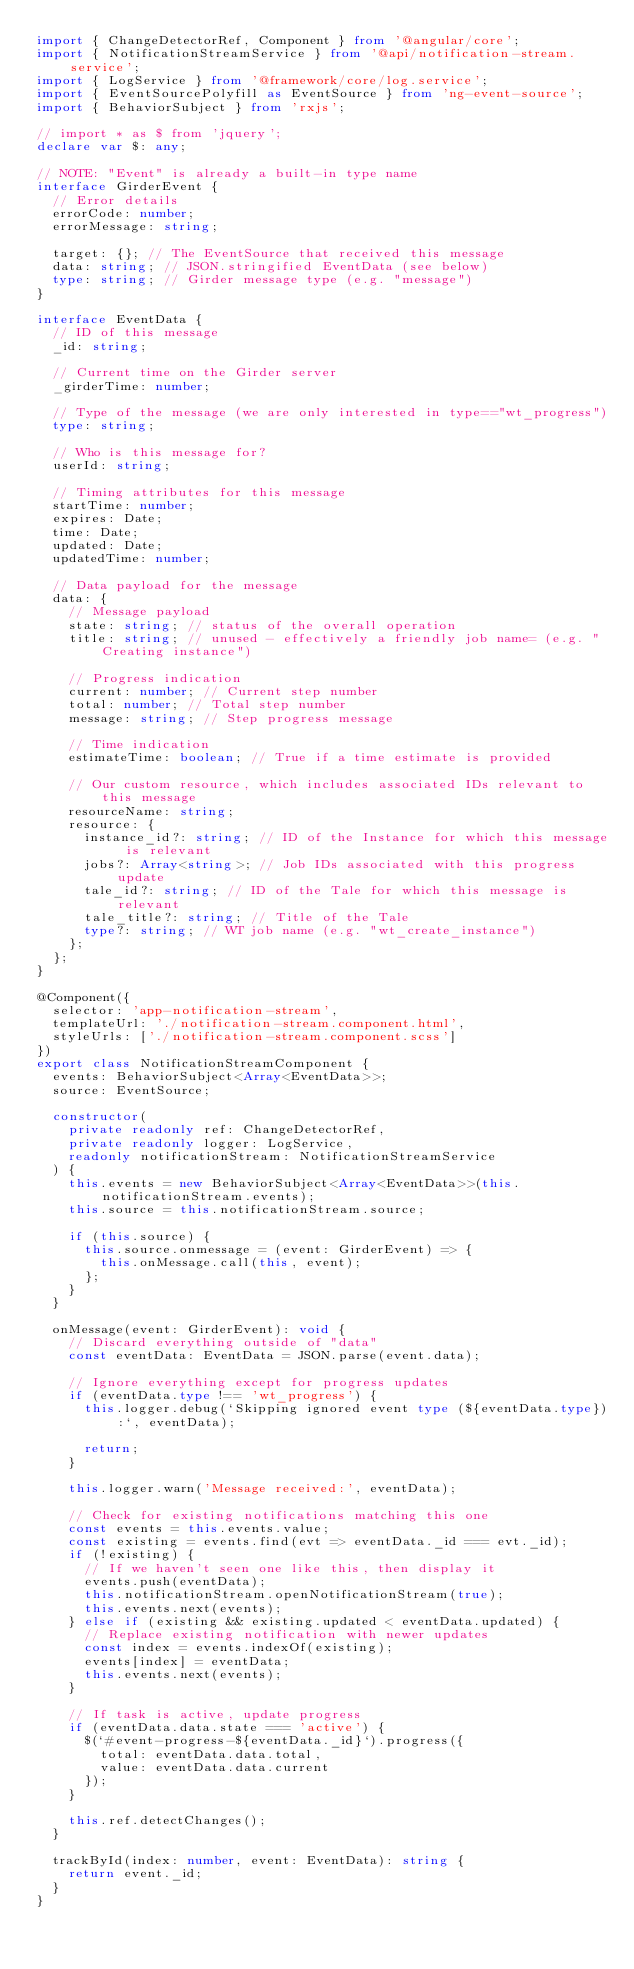<code> <loc_0><loc_0><loc_500><loc_500><_TypeScript_>import { ChangeDetectorRef, Component } from '@angular/core';
import { NotificationStreamService } from '@api/notification-stream.service';
import { LogService } from '@framework/core/log.service';
import { EventSourcePolyfill as EventSource } from 'ng-event-source';
import { BehaviorSubject } from 'rxjs';

// import * as $ from 'jquery';
declare var $: any;

// NOTE: "Event" is already a built-in type name
interface GirderEvent {
  // Error details
  errorCode: number;
  errorMessage: string;

  target: {}; // The EventSource that received this message
  data: string; // JSON.stringified EventData (see below)
  type: string; // Girder message type (e.g. "message")
}

interface EventData {
  // ID of this message
  _id: string;

  // Current time on the Girder server
  _girderTime: number;

  // Type of the message (we are only interested in type=="wt_progress")
  type: string;

  // Who is this message for?
  userId: string;

  // Timing attributes for this message
  startTime: number;
  expires: Date;
  time: Date;
  updated: Date;
  updatedTime: number;

  // Data payload for the message
  data: {
    // Message payload
    state: string; // status of the overall operation
    title: string; // unused - effectively a friendly job name= (e.g. "Creating instance")

    // Progress indication
    current: number; // Current step number
    total: number; // Total step number
    message: string; // Step progress message

    // Time indication
    estimateTime: boolean; // True if a time estimate is provided

    // Our custom resource, which includes associated IDs relevant to this message
    resourceName: string;
    resource: {
      instance_id?: string; // ID of the Instance for which this message is relevant
      jobs?: Array<string>; // Job IDs associated with this progress update
      tale_id?: string; // ID of the Tale for which this message is relevant
      tale_title?: string; // Title of the Tale
      type?: string; // WT job name (e.g. "wt_create_instance")
    };
  };
}

@Component({
  selector: 'app-notification-stream',
  templateUrl: './notification-stream.component.html',
  styleUrls: ['./notification-stream.component.scss']
})
export class NotificationStreamComponent {
  events: BehaviorSubject<Array<EventData>>;
  source: EventSource;

  constructor(
    private readonly ref: ChangeDetectorRef,
    private readonly logger: LogService,
    readonly notificationStream: NotificationStreamService
  ) {
    this.events = new BehaviorSubject<Array<EventData>>(this.notificationStream.events);
    this.source = this.notificationStream.source;

    if (this.source) {
      this.source.onmessage = (event: GirderEvent) => {
        this.onMessage.call(this, event);
      };
    }
  }

  onMessage(event: GirderEvent): void {
    // Discard everything outside of "data"
    const eventData: EventData = JSON.parse(event.data);

    // Ignore everything except for progress updates
    if (eventData.type !== 'wt_progress') {
      this.logger.debug(`Skipping ignored event type (${eventData.type}):`, eventData);

      return;
    }

    this.logger.warn('Message received:', eventData);

    // Check for existing notifications matching this one
    const events = this.events.value;
    const existing = events.find(evt => eventData._id === evt._id);
    if (!existing) {
      // If we haven't seen one like this, then display it
      events.push(eventData);
      this.notificationStream.openNotificationStream(true);
      this.events.next(events);
    } else if (existing && existing.updated < eventData.updated) {
      // Replace existing notification with newer updates
      const index = events.indexOf(existing);
      events[index] = eventData;
      this.events.next(events);
    }

    // If task is active, update progress
    if (eventData.data.state === 'active') {
      $(`#event-progress-${eventData._id}`).progress({
        total: eventData.data.total,
        value: eventData.data.current
      });
    }

    this.ref.detectChanges();
  }

  trackById(index: number, event: EventData): string {
    return event._id;
  }
}
</code> 